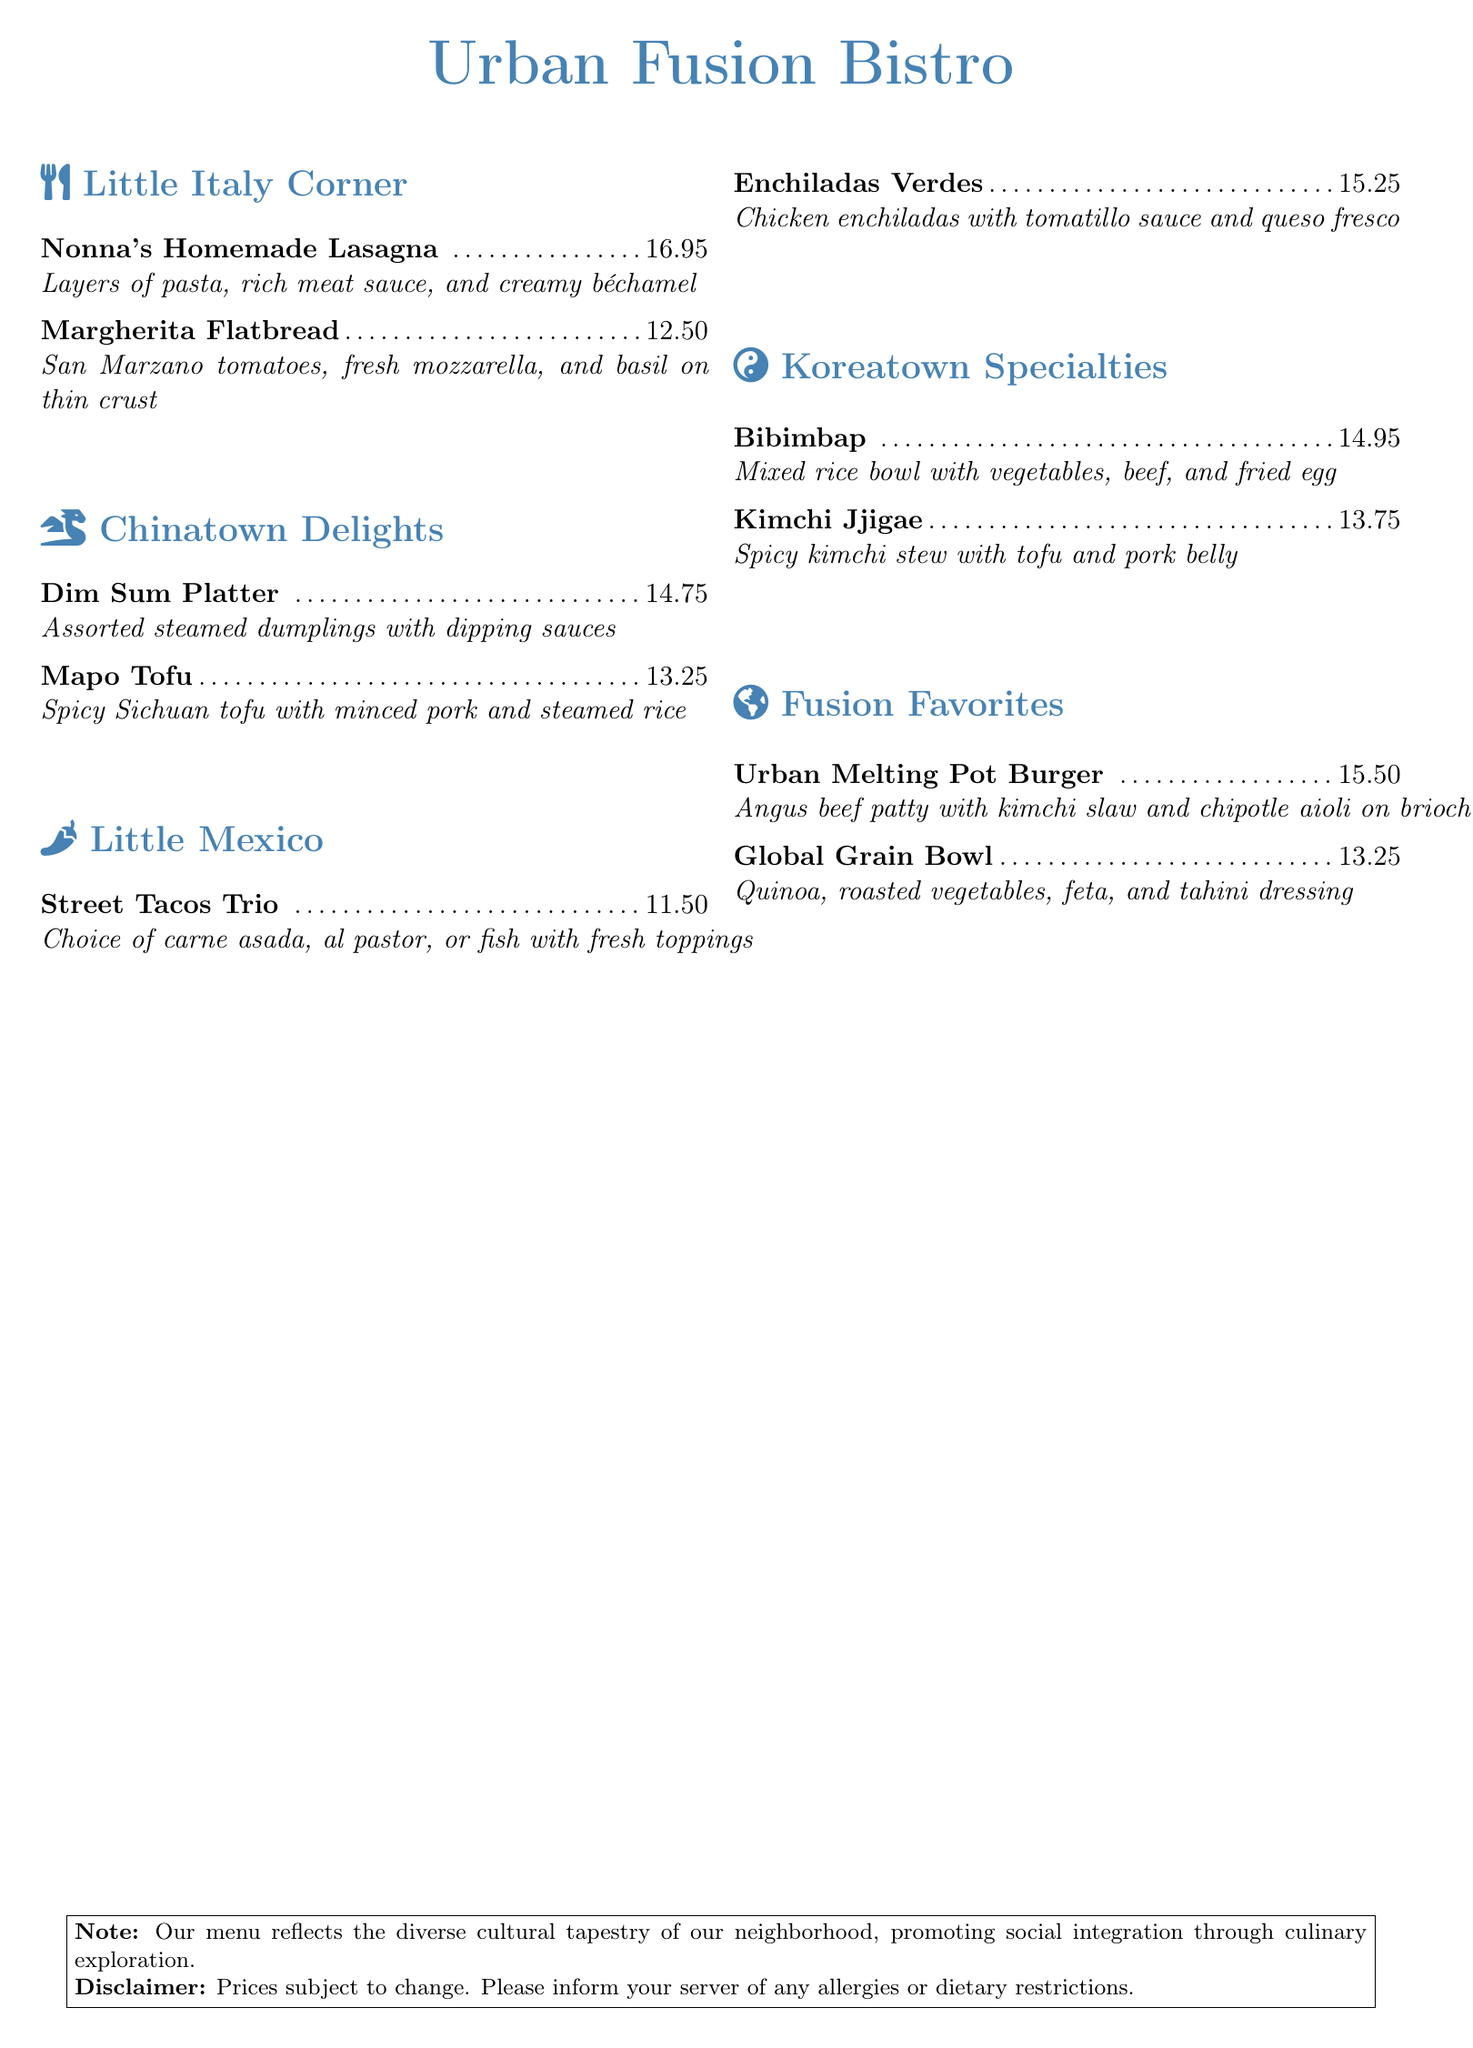what is the name of the restaurant? The name of the restaurant is prominently displayed at the top of the document.
Answer: Urban Fusion Bistro how much does the Margherita Flatbread cost? The price of the Margherita Flatbread is listed next to the dish name in the menu section.
Answer: $12.50 which section includes spicy dishes? The reasoning involves identifying sections that contain dishes known for their spiciness.
Answer: Koreatown Specialties what type of cuisine does 'Nonna's Homemade Lasagna' represent? The dish 'Nonna's Homemade Lasagna' is listed under the Little Italy Corner section, indicating the cuisine type.
Answer: Italian how many tacos are included in the Street Tacos Trio? The question pertains to the description of the Street Tacos Trio in the Little Mexico section.
Answer: Trio which dish features kimchi? The dish featuring kimchi is specified in the Koreatown Specialties section of the menu.
Answer: Kimchi Jjigae is there a vegetarian option on the menu? The inquiry is about identifying vegetarian options within the menu items listed.
Answer: Global Grain Bowl what is the description of the Dim Sum Platter? The description provided details the composition and presentation of the Dim Sum Platter in the menu.
Answer: Assorted steamed dumplings with dipping sauces what type of meat is used in the Enchiladas Verdes? The question seeks to find out the type of meat specified alongside the Enchiladas in the menu.
Answer: Chicken 